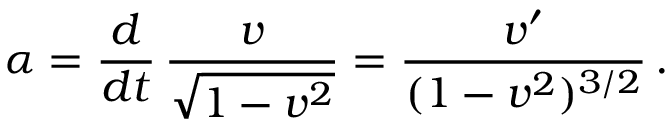Convert formula to latex. <formula><loc_0><loc_0><loc_500><loc_500>\alpha = \frac { d } { d t } \, \frac { v } { \sqrt { 1 - v ^ { 2 } } } = \frac { v ^ { \prime } } { ( 1 - v ^ { 2 } ) ^ { 3 / 2 } } \, .</formula> 